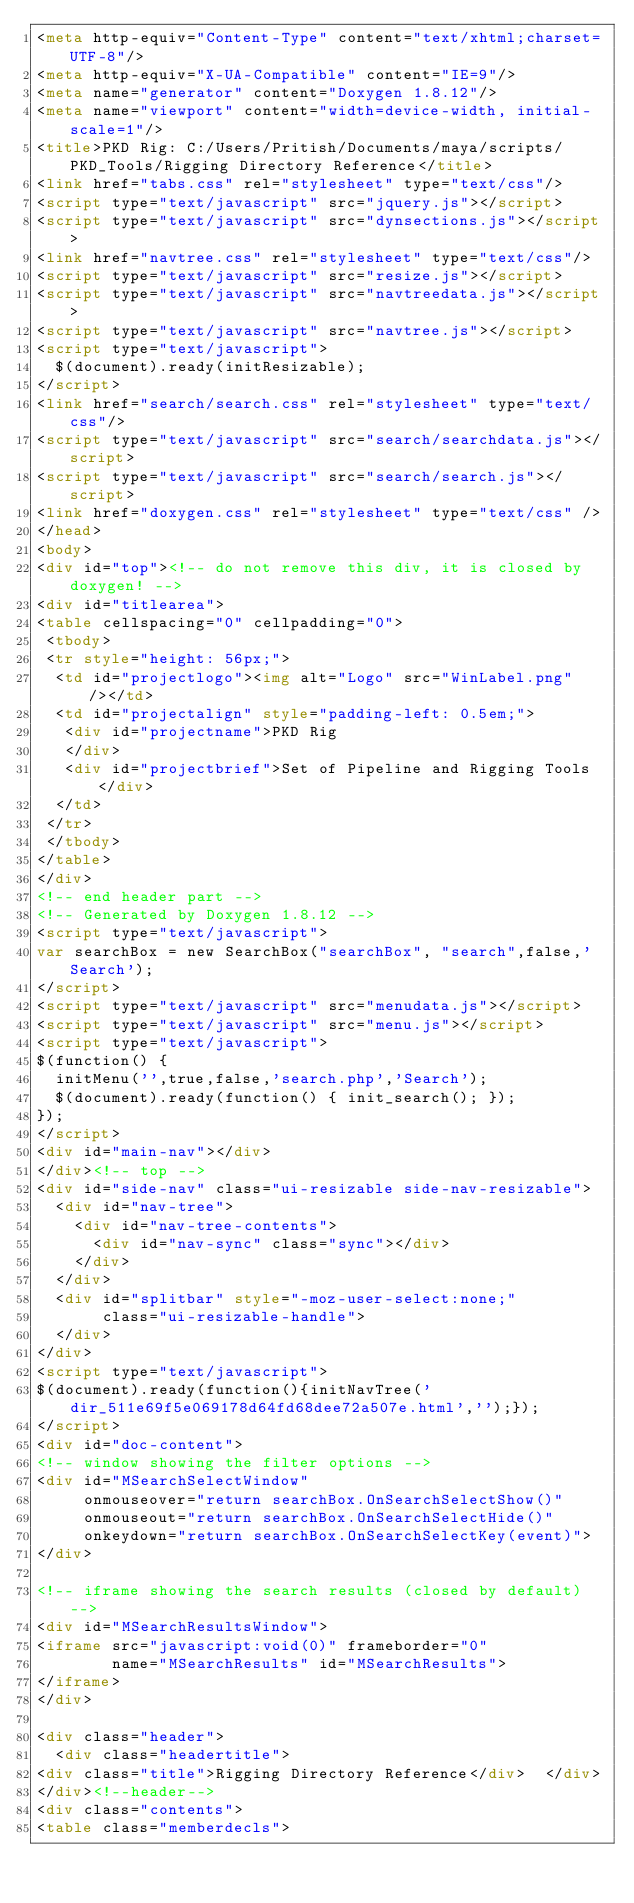<code> <loc_0><loc_0><loc_500><loc_500><_HTML_><meta http-equiv="Content-Type" content="text/xhtml;charset=UTF-8"/>
<meta http-equiv="X-UA-Compatible" content="IE=9"/>
<meta name="generator" content="Doxygen 1.8.12"/>
<meta name="viewport" content="width=device-width, initial-scale=1"/>
<title>PKD Rig: C:/Users/Pritish/Documents/maya/scripts/PKD_Tools/Rigging Directory Reference</title>
<link href="tabs.css" rel="stylesheet" type="text/css"/>
<script type="text/javascript" src="jquery.js"></script>
<script type="text/javascript" src="dynsections.js"></script>
<link href="navtree.css" rel="stylesheet" type="text/css"/>
<script type="text/javascript" src="resize.js"></script>
<script type="text/javascript" src="navtreedata.js"></script>
<script type="text/javascript" src="navtree.js"></script>
<script type="text/javascript">
  $(document).ready(initResizable);
</script>
<link href="search/search.css" rel="stylesheet" type="text/css"/>
<script type="text/javascript" src="search/searchdata.js"></script>
<script type="text/javascript" src="search/search.js"></script>
<link href="doxygen.css" rel="stylesheet" type="text/css" />
</head>
<body>
<div id="top"><!-- do not remove this div, it is closed by doxygen! -->
<div id="titlearea">
<table cellspacing="0" cellpadding="0">
 <tbody>
 <tr style="height: 56px;">
  <td id="projectlogo"><img alt="Logo" src="WinLabel.png"/></td>
  <td id="projectalign" style="padding-left: 0.5em;">
   <div id="projectname">PKD Rig
   </div>
   <div id="projectbrief">Set of Pipeline and Rigging Tools</div>
  </td>
 </tr>
 </tbody>
</table>
</div>
<!-- end header part -->
<!-- Generated by Doxygen 1.8.12 -->
<script type="text/javascript">
var searchBox = new SearchBox("searchBox", "search",false,'Search');
</script>
<script type="text/javascript" src="menudata.js"></script>
<script type="text/javascript" src="menu.js"></script>
<script type="text/javascript">
$(function() {
  initMenu('',true,false,'search.php','Search');
  $(document).ready(function() { init_search(); });
});
</script>
<div id="main-nav"></div>
</div><!-- top -->
<div id="side-nav" class="ui-resizable side-nav-resizable">
  <div id="nav-tree">
    <div id="nav-tree-contents">
      <div id="nav-sync" class="sync"></div>
    </div>
  </div>
  <div id="splitbar" style="-moz-user-select:none;" 
       class="ui-resizable-handle">
  </div>
</div>
<script type="text/javascript">
$(document).ready(function(){initNavTree('dir_511e69f5e069178d64fd68dee72a507e.html','');});
</script>
<div id="doc-content">
<!-- window showing the filter options -->
<div id="MSearchSelectWindow"
     onmouseover="return searchBox.OnSearchSelectShow()"
     onmouseout="return searchBox.OnSearchSelectHide()"
     onkeydown="return searchBox.OnSearchSelectKey(event)">
</div>

<!-- iframe showing the search results (closed by default) -->
<div id="MSearchResultsWindow">
<iframe src="javascript:void(0)" frameborder="0" 
        name="MSearchResults" id="MSearchResults">
</iframe>
</div>

<div class="header">
  <div class="headertitle">
<div class="title">Rigging Directory Reference</div>  </div>
</div><!--header-->
<div class="contents">
<table class="memberdecls"></code> 